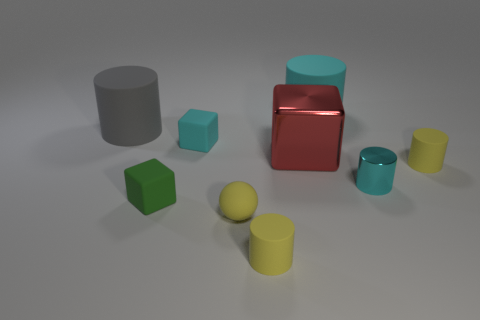Are the gray cylinder and the small sphere made of the same material? The gray cylinder and the small sphere exhibit similar matte surface textures and lack of reflections, suggesting they could be made of the same or similar types of materials, often associated with objects that are not metallic or shiny. However, without further context or tactile examination, we cannot conclusively determine the exact material composition of the objects. 